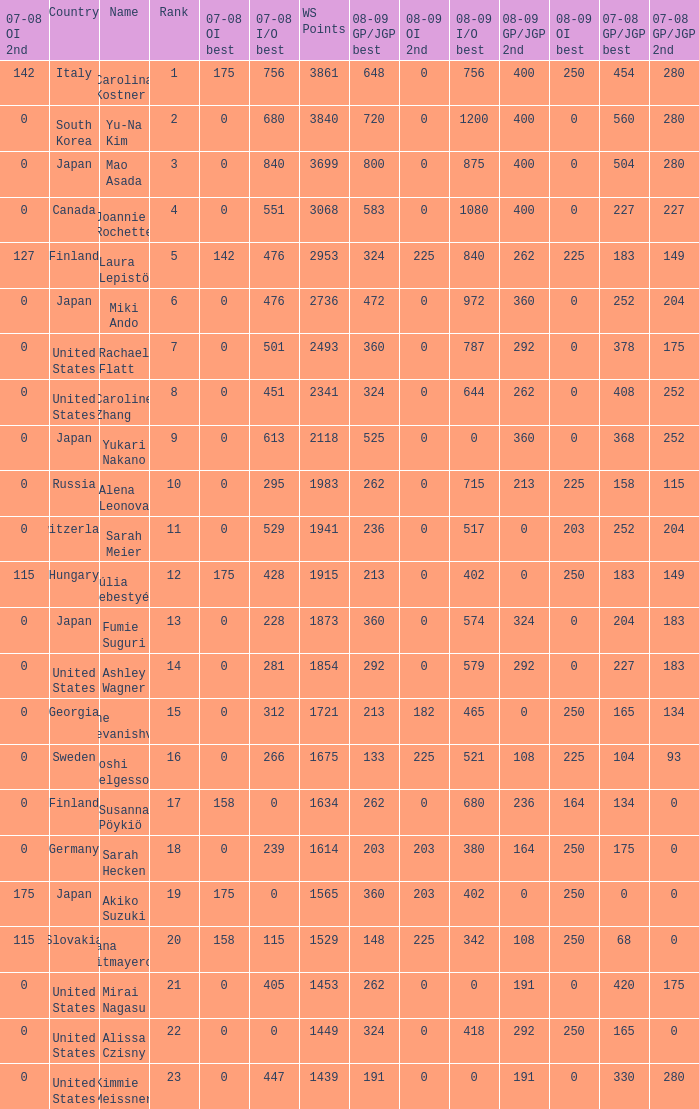08-09 gp/jgp 2nd is 213 and ws points will be what maximum 1983.0. 